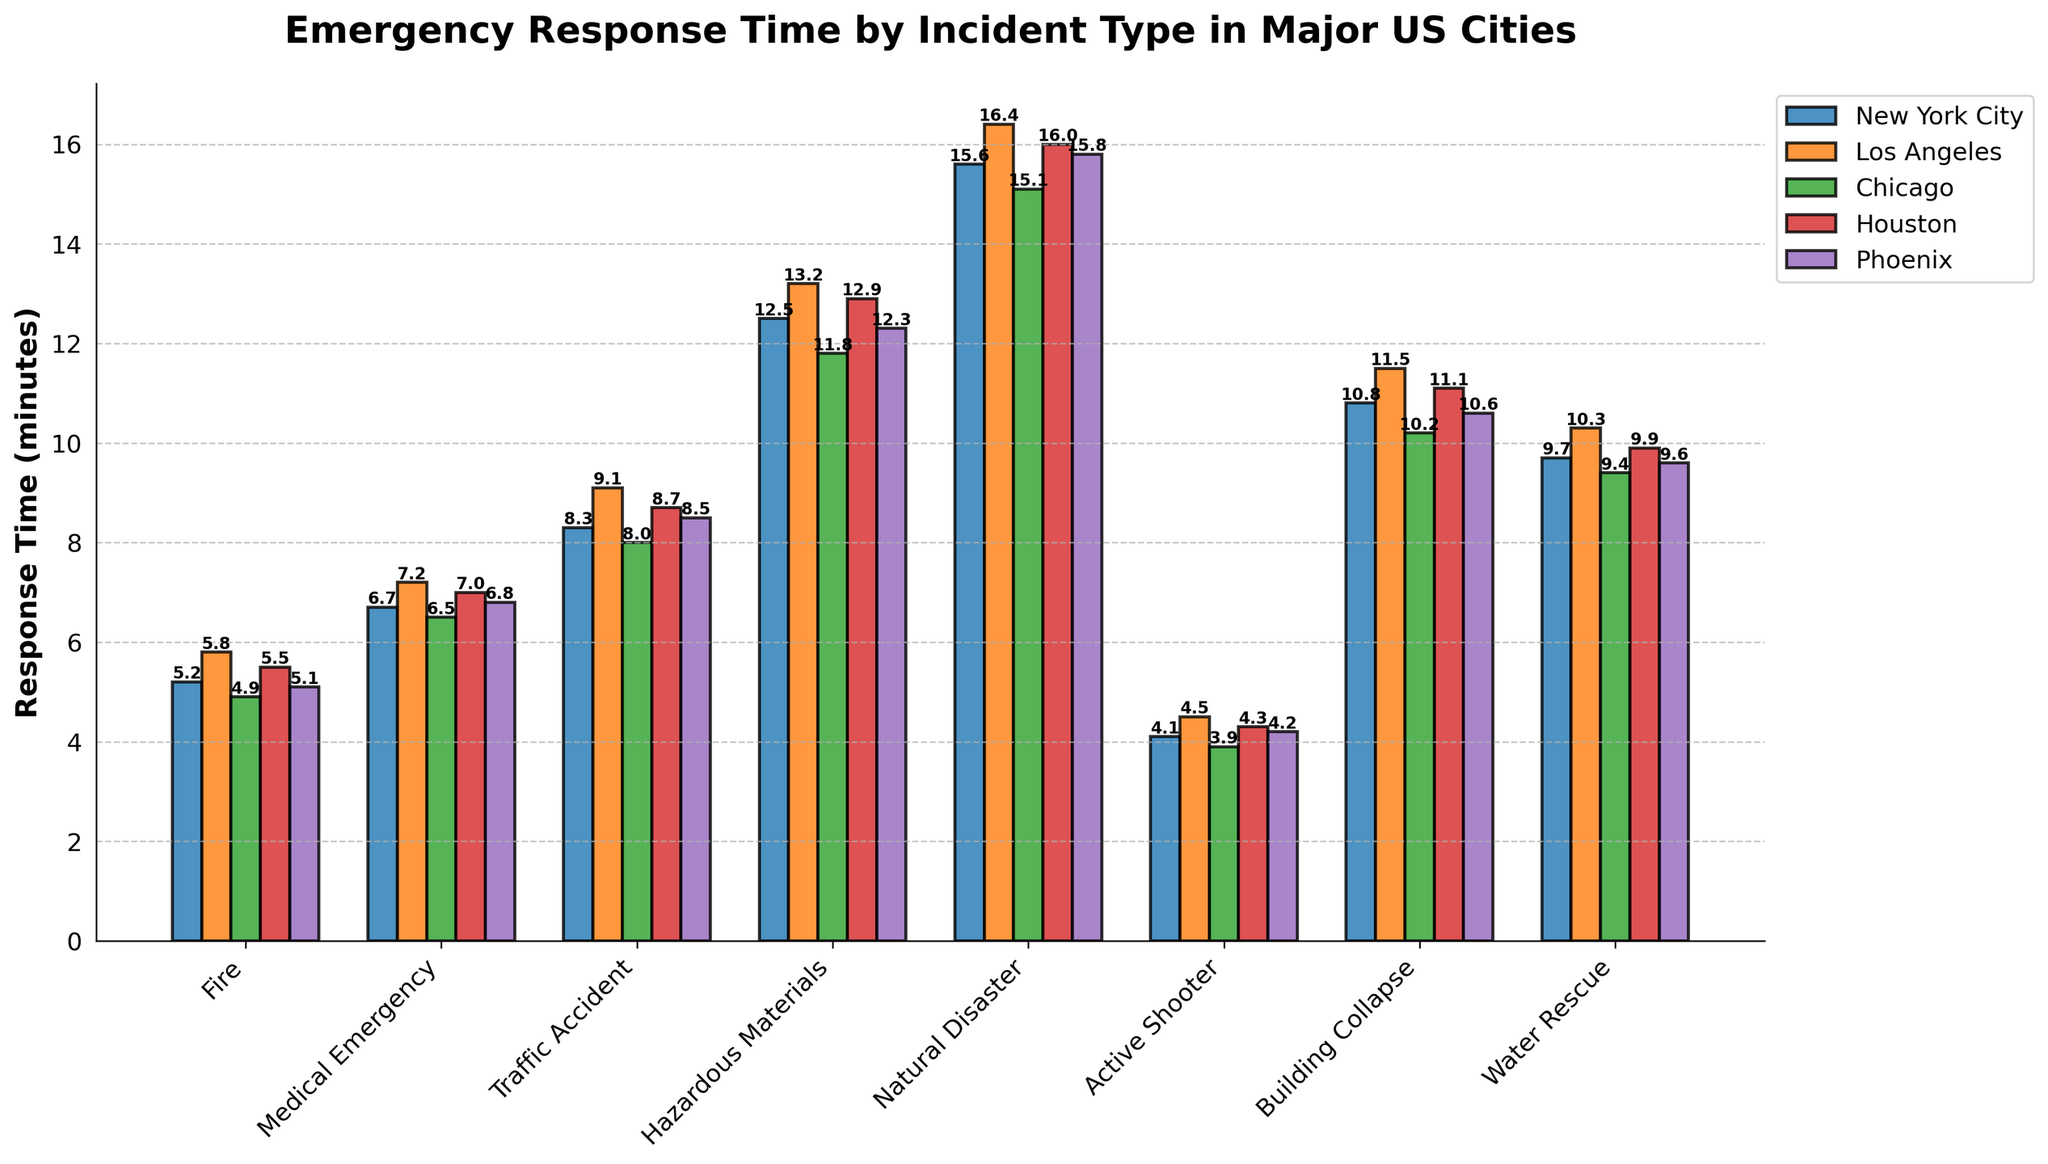What's the average response time for a Medical Emergency across all cities? Calculate each city's response time for a Medical Emergency (6.7 + 7.2 + 6.5 + 7.0 + 6.8) and then divide by the number of cities (5). This gives us (34.2 / 5).
Answer: 6.84 Which city has the shortest response time for an Active Shooter incident? Look at the response times for the Active Shooter incident across all cities. The values are New York City: 4.1, Los Angeles: 4.5, Chicago: 3.9, Houston: 4.3, Phoenix: 4.2. Chicago has the shortest time.
Answer: Chicago In which city does the response time for a Hazardous Materials incident exceed 13 minutes? Check the response times for the Hazardous Materials incidents for each city: New York City: 12.5, Los Angeles: 13.2, Chicago: 11.8, Houston: 12.9, Phoenix: 12.3. Only Los Angeles exceeds 13 minutes.
Answer: Los Angeles How much longer is the response time for a Natural Disaster in Los Angeles compared to Chicago? Find both values: Los Angeles: 16.4 and Chicago: 15.1. Subtract them to find the difference (16.4 - 15.1).
Answer: 1.3 minutes Which incident type has the highest average response time across all cities? Calculate the average response time for each incident type across all cities and then identify the maximum value. The incident types and their average times are Fire: 5.3, Medical Emergency: 6.84, Traffic Accident: 8.52, Hazardous Materials: 12.54, Natural Disaster: 15.78, Active Shooter: 4.2, Building Collapse: 10.84, Water Rescue: 9.78. Natural Disaster has the highest average time.
Answer: Natural Disaster Compare the response time for a Building Collapse in New York City and Phoenix, and identify the visual difference in bar length. Look at the response times for Building Collapse in New York City and Phoenix. The values are New York City: 10.8 and Phoenix: 10.6. New York City's bar is slightly taller.
Answer: New York City's bar is slightly taller Which incident types have a response time longer than 9 minutes in Houston? Check the response times for each incident in Houston: Fire: 5.5, Medical Emergency: 7.0, Traffic Accident: 8.7, Hazardous Materials: 12.9, Natural Disaster: 16.0, Active Shooter: 4.3, Building Collapse: 11.1, Water Rescue: 9.9. Hazardous Materials, Natural Disaster, Building Collapse, and Water Rescue exceed 9 minutes.
Answer: Hazardous Materials, Natural Disaster, Building Collapse, Water Rescue Is there any city where the response time for Fire incidents is shorter than for Active Shooter incidents? Compare the response times for Fire and Active Shooter incidents in each city: New York City: Fire 5.2 vs. Active Shooter 4.1, Los Angeles: Fire 5.8 vs. Active Shooter 4.5, Chicago: Fire 4.9 vs. Active Shooter 3.9, Houston: Fire 5.5 vs. Active Shooter 4.3, Phoenix: Fire 5.1 vs. Active Shooter 4.2. In all cities, Fire incidents have a longer response time compared to Active Shooter incidents.
Answer: No Which city has the longest response time for Water Rescue incidents? Check the response times for Water Rescue incidents across all cities: New York City: 9.7, Los Angeles: 10.3, Chicago: 9.4, Houston: 9.9, Phoenix: 9.6. Los Angeles has the longest time.
Answer: Los Angeles 